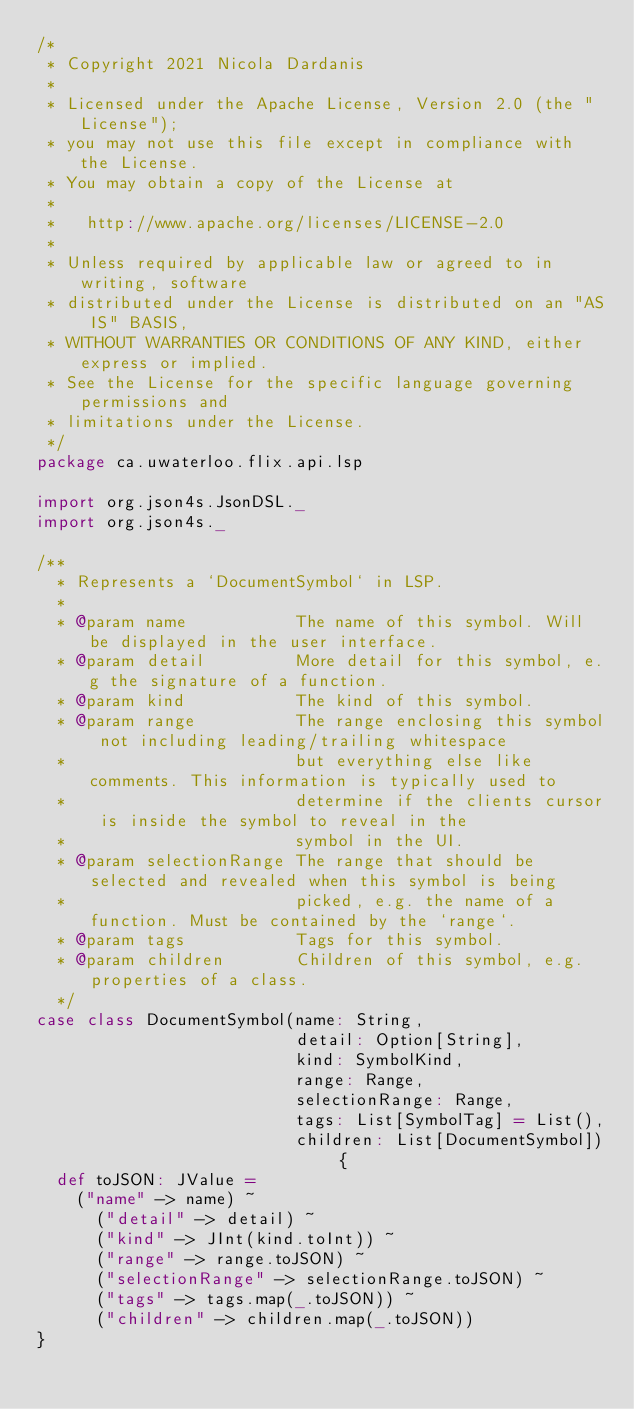Convert code to text. <code><loc_0><loc_0><loc_500><loc_500><_Scala_>/*
 * Copyright 2021 Nicola Dardanis
 *
 * Licensed under the Apache License, Version 2.0 (the "License");
 * you may not use this file except in compliance with the License.
 * You may obtain a copy of the License at
 *
 *   http://www.apache.org/licenses/LICENSE-2.0
 *
 * Unless required by applicable law or agreed to in writing, software
 * distributed under the License is distributed on an "AS IS" BASIS,
 * WITHOUT WARRANTIES OR CONDITIONS OF ANY KIND, either express or implied.
 * See the License for the specific language governing permissions and
 * limitations under the License.
 */
package ca.uwaterloo.flix.api.lsp

import org.json4s.JsonDSL._
import org.json4s._

/**
  * Represents a `DocumentSymbol` in LSP.
  *
  * @param name           The name of this symbol. Will be displayed in the user interface.
  * @param detail         More detail for this symbol, e.g the signature of a function.
  * @param kind           The kind of this symbol.
  * @param range          The range enclosing this symbol not including leading/trailing whitespace
  *                       but everything else like comments. This information is typically used to
  *                       determine if the clients cursor is inside the symbol to reveal in the
  *                       symbol in the UI.
  * @param selectionRange The range that should be selected and revealed when this symbol is being
  *                       picked, e.g. the name of a function. Must be contained by the `range`.
  * @param tags           Tags for this symbol.
  * @param children       Children of this symbol, e.g. properties of a class.
  */
case class DocumentSymbol(name: String,
                          detail: Option[String],
                          kind: SymbolKind,
                          range: Range,
                          selectionRange: Range,
                          tags: List[SymbolTag] = List(),
                          children: List[DocumentSymbol]) {
  def toJSON: JValue =
    ("name" -> name) ~
      ("detail" -> detail) ~
      ("kind" -> JInt(kind.toInt)) ~
      ("range" -> range.toJSON) ~
      ("selectionRange" -> selectionRange.toJSON) ~
      ("tags" -> tags.map(_.toJSON)) ~
      ("children" -> children.map(_.toJSON))
}

</code> 